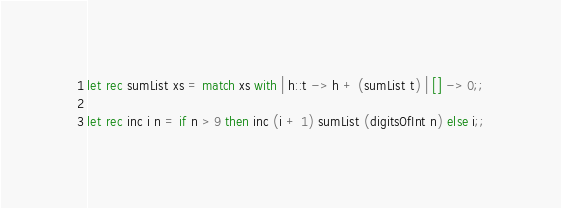Convert code to text. <code><loc_0><loc_0><loc_500><loc_500><_OCaml_>let rec sumList xs = match xs with | h::t -> h + (sumList t) | [] -> 0;;

let rec inc i n = if n > 9 then inc (i + 1) sumList (digitsOfInt n) else i;;
</code> 